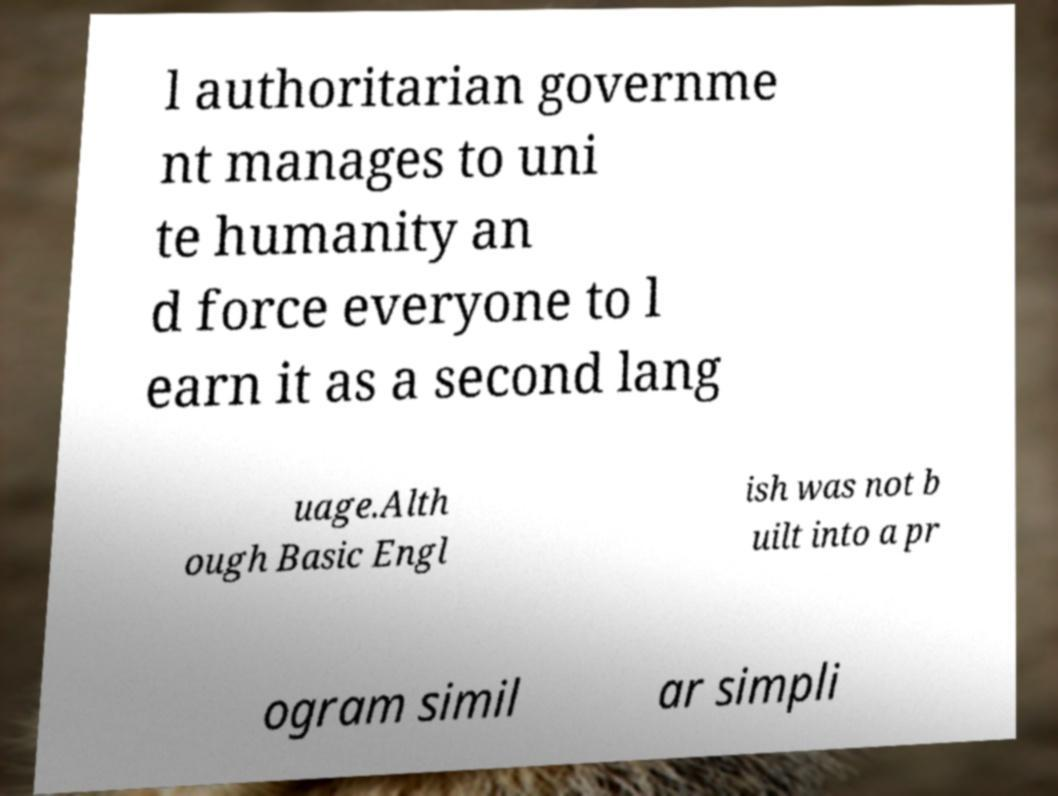Please identify and transcribe the text found in this image. l authoritarian governme nt manages to uni te humanity an d force everyone to l earn it as a second lang uage.Alth ough Basic Engl ish was not b uilt into a pr ogram simil ar simpli 